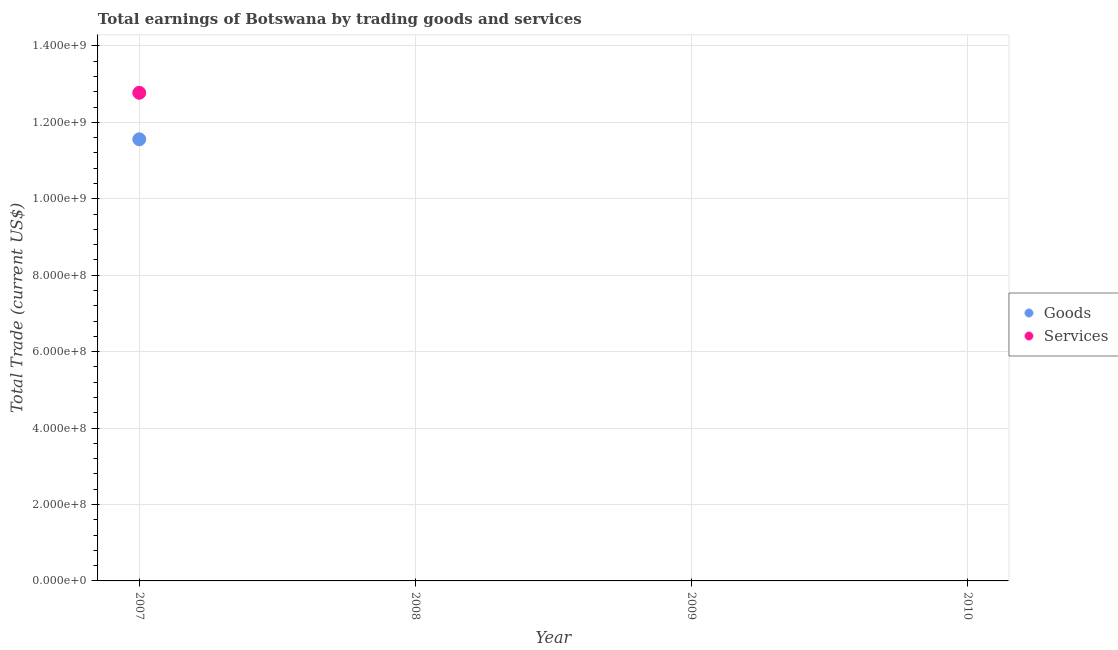Is the number of dotlines equal to the number of legend labels?
Offer a terse response. No. What is the amount earned by trading services in 2010?
Ensure brevity in your answer.  0. Across all years, what is the maximum amount earned by trading services?
Your answer should be compact. 1.28e+09. Across all years, what is the minimum amount earned by trading goods?
Give a very brief answer. 0. In which year was the amount earned by trading goods maximum?
Provide a succinct answer. 2007. What is the total amount earned by trading services in the graph?
Offer a very short reply. 1.28e+09. What is the difference between the amount earned by trading services in 2007 and the amount earned by trading goods in 2009?
Offer a very short reply. 1.28e+09. What is the average amount earned by trading services per year?
Your answer should be compact. 3.19e+08. In the year 2007, what is the difference between the amount earned by trading goods and amount earned by trading services?
Ensure brevity in your answer.  -1.22e+08. What is the difference between the highest and the lowest amount earned by trading services?
Give a very brief answer. 1.28e+09. Does the amount earned by trading goods monotonically increase over the years?
Your answer should be very brief. No. Is the amount earned by trading services strictly greater than the amount earned by trading goods over the years?
Make the answer very short. No. Is the amount earned by trading services strictly less than the amount earned by trading goods over the years?
Provide a succinct answer. No. Are the values on the major ticks of Y-axis written in scientific E-notation?
Ensure brevity in your answer.  Yes. Does the graph contain any zero values?
Keep it short and to the point. Yes. Does the graph contain grids?
Your answer should be compact. Yes. Where does the legend appear in the graph?
Provide a succinct answer. Center right. How many legend labels are there?
Your response must be concise. 2. How are the legend labels stacked?
Offer a terse response. Vertical. What is the title of the graph?
Offer a very short reply. Total earnings of Botswana by trading goods and services. What is the label or title of the Y-axis?
Offer a very short reply. Total Trade (current US$). What is the Total Trade (current US$) in Goods in 2007?
Provide a short and direct response. 1.16e+09. What is the Total Trade (current US$) of Services in 2007?
Ensure brevity in your answer.  1.28e+09. What is the Total Trade (current US$) in Goods in 2008?
Offer a terse response. 0. What is the Total Trade (current US$) in Services in 2009?
Provide a succinct answer. 0. What is the Total Trade (current US$) in Goods in 2010?
Provide a short and direct response. 0. Across all years, what is the maximum Total Trade (current US$) of Goods?
Offer a very short reply. 1.16e+09. Across all years, what is the maximum Total Trade (current US$) of Services?
Ensure brevity in your answer.  1.28e+09. Across all years, what is the minimum Total Trade (current US$) in Goods?
Give a very brief answer. 0. What is the total Total Trade (current US$) of Goods in the graph?
Your response must be concise. 1.16e+09. What is the total Total Trade (current US$) of Services in the graph?
Provide a succinct answer. 1.28e+09. What is the average Total Trade (current US$) of Goods per year?
Give a very brief answer. 2.89e+08. What is the average Total Trade (current US$) of Services per year?
Your answer should be very brief. 3.19e+08. In the year 2007, what is the difference between the Total Trade (current US$) in Goods and Total Trade (current US$) in Services?
Your response must be concise. -1.22e+08. What is the difference between the highest and the lowest Total Trade (current US$) of Goods?
Provide a succinct answer. 1.16e+09. What is the difference between the highest and the lowest Total Trade (current US$) in Services?
Give a very brief answer. 1.28e+09. 